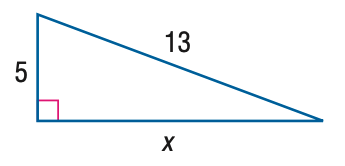Answer the mathemtical geometry problem and directly provide the correct option letter.
Question: Find x.
Choices: A: 9 B: 10 C: 11 D: 12 D 